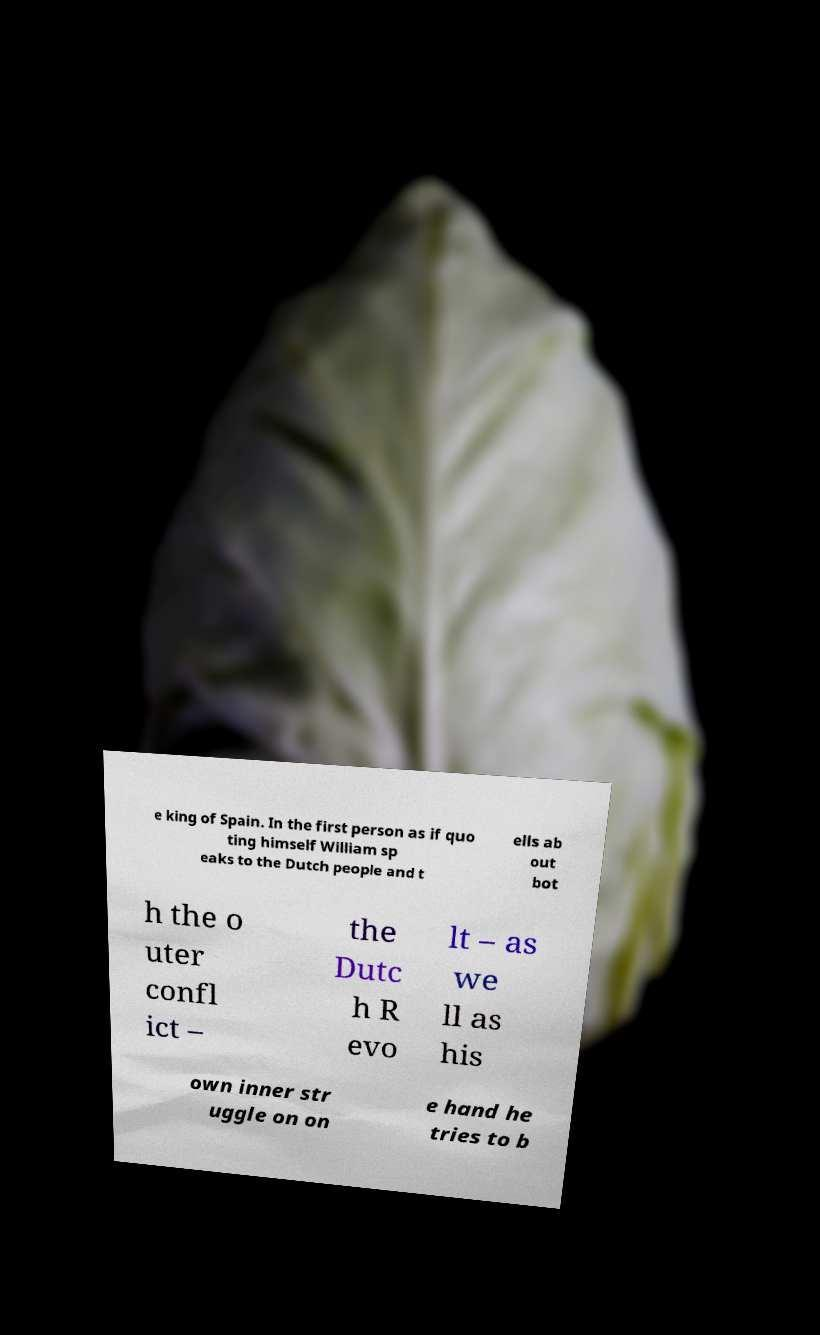Could you assist in decoding the text presented in this image and type it out clearly? e king of Spain. In the first person as if quo ting himself William sp eaks to the Dutch people and t ells ab out bot h the o uter confl ict – the Dutc h R evo lt – as we ll as his own inner str uggle on on e hand he tries to b 